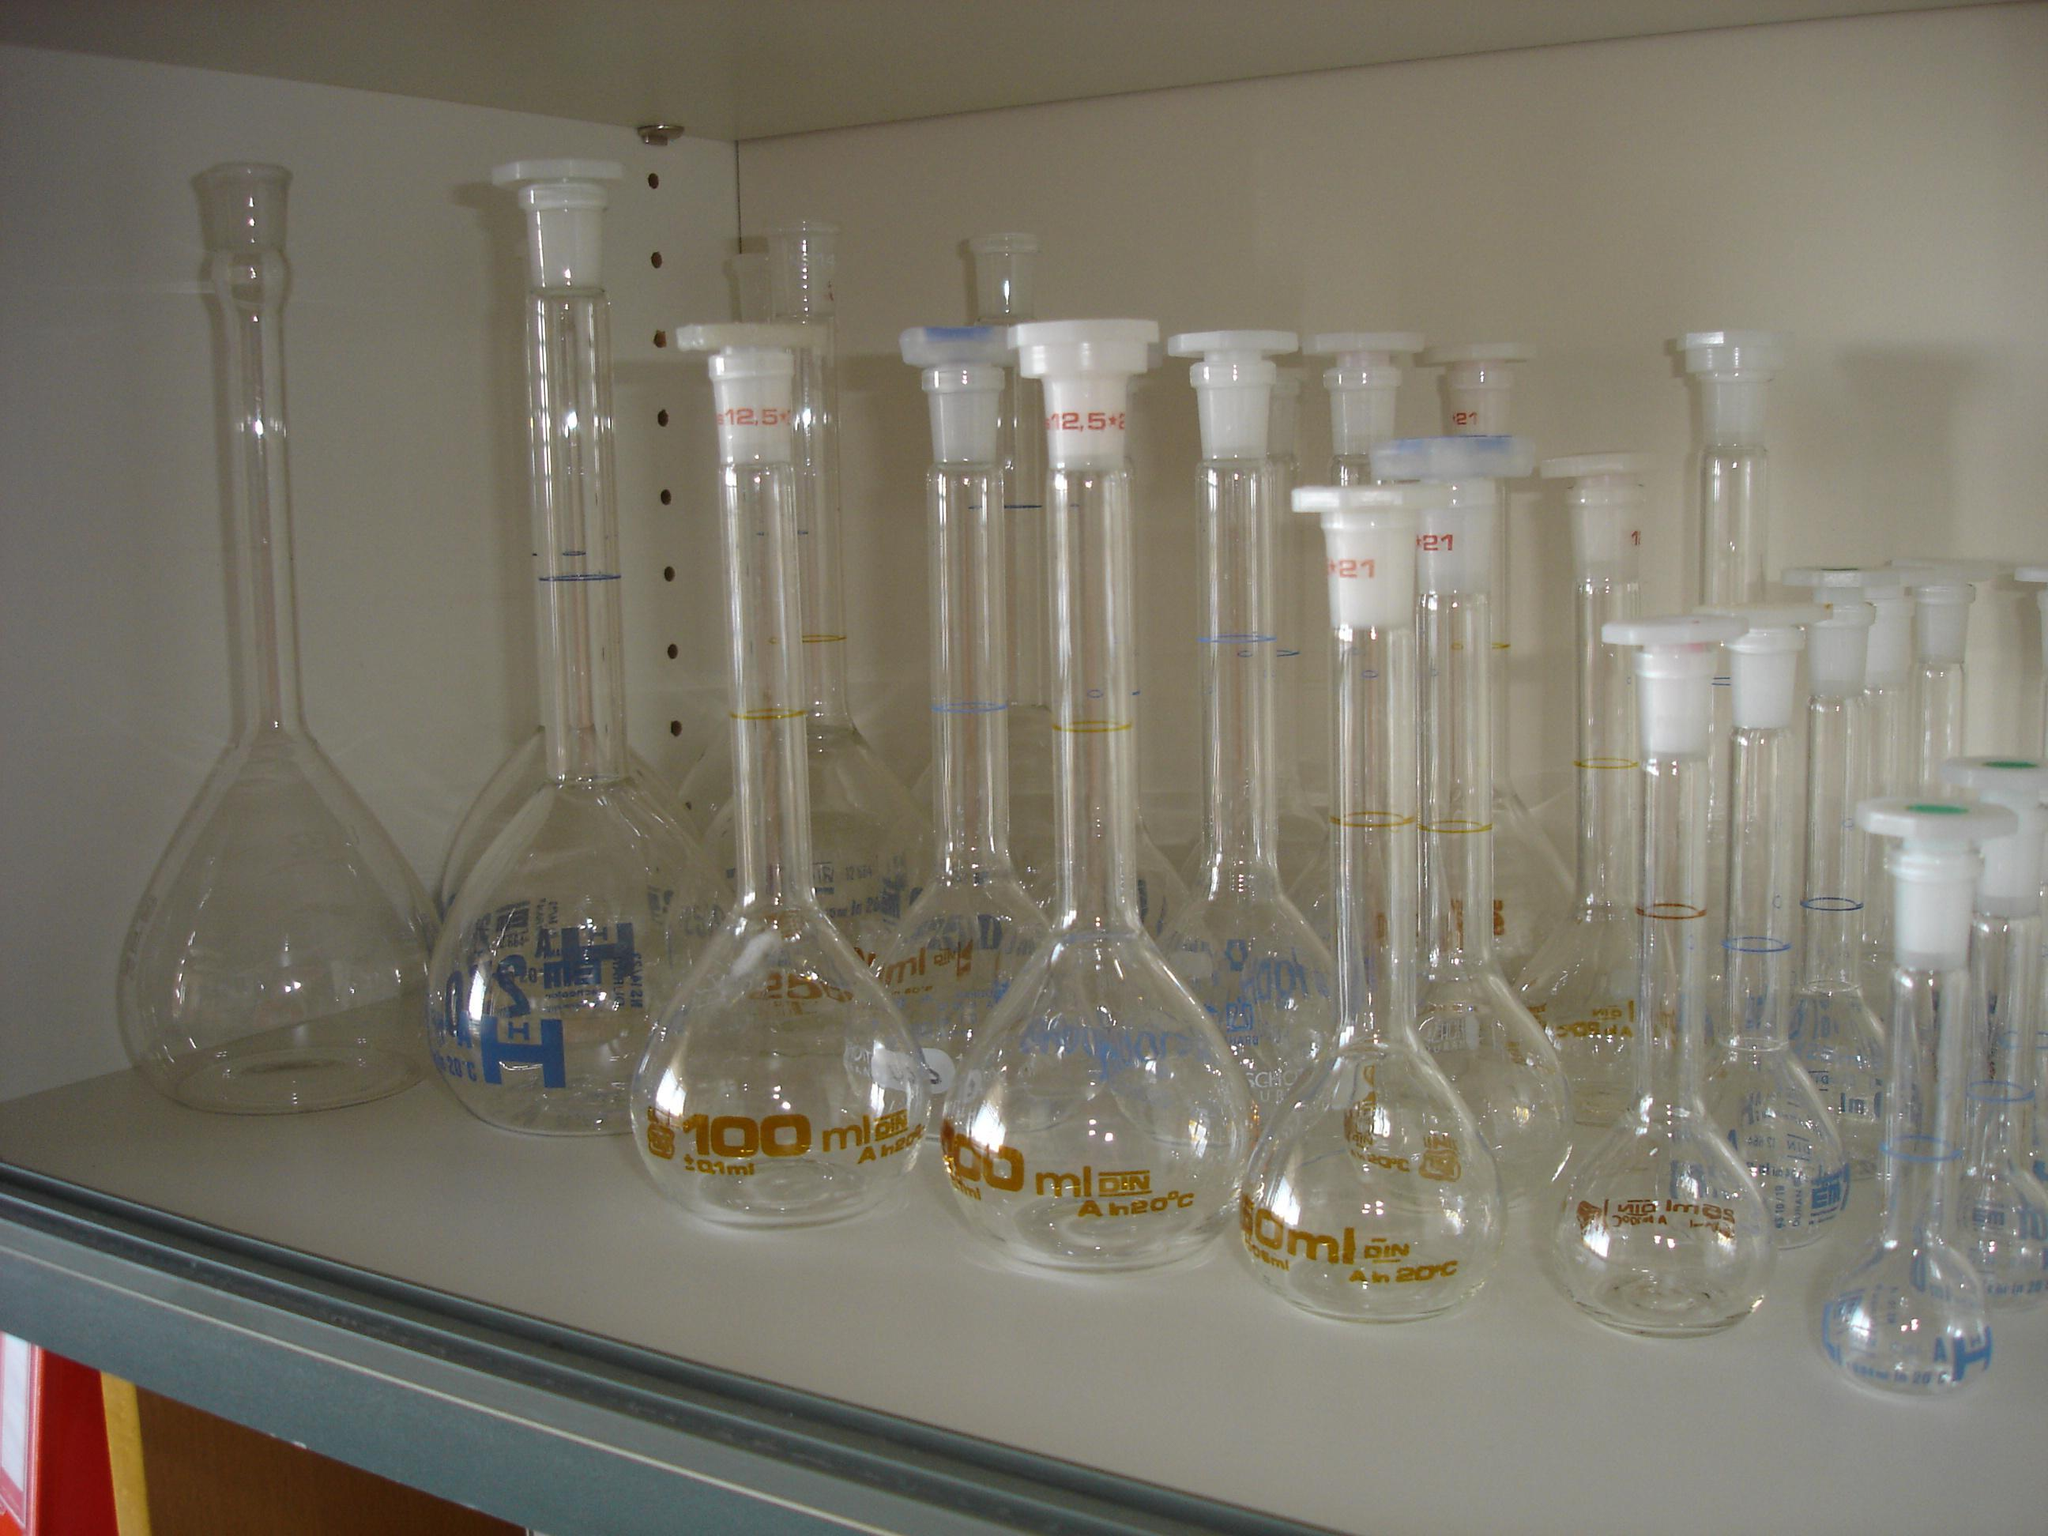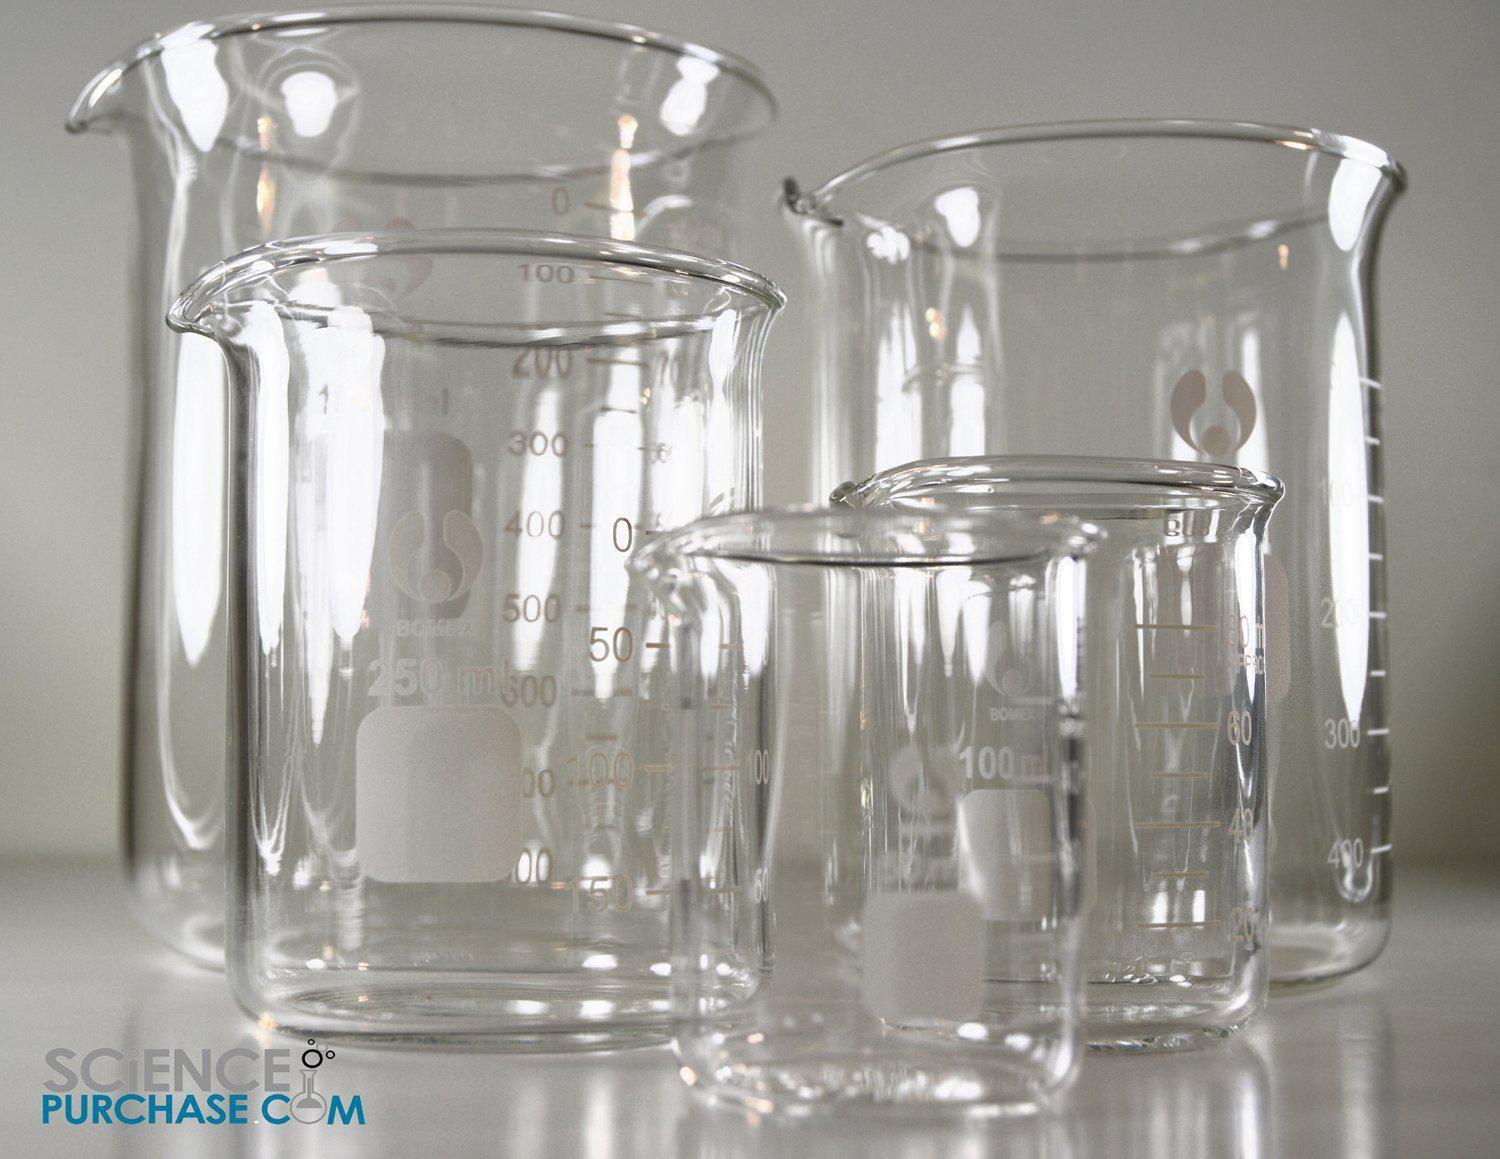The first image is the image on the left, the second image is the image on the right. For the images displayed, is the sentence "At least one of the photos contains three or more pieces of glassware." factually correct? Answer yes or no. Yes. The first image is the image on the left, the second image is the image on the right. For the images displayed, is the sentence "A long thin glass stick is in at least one beaker." factually correct? Answer yes or no. No. 